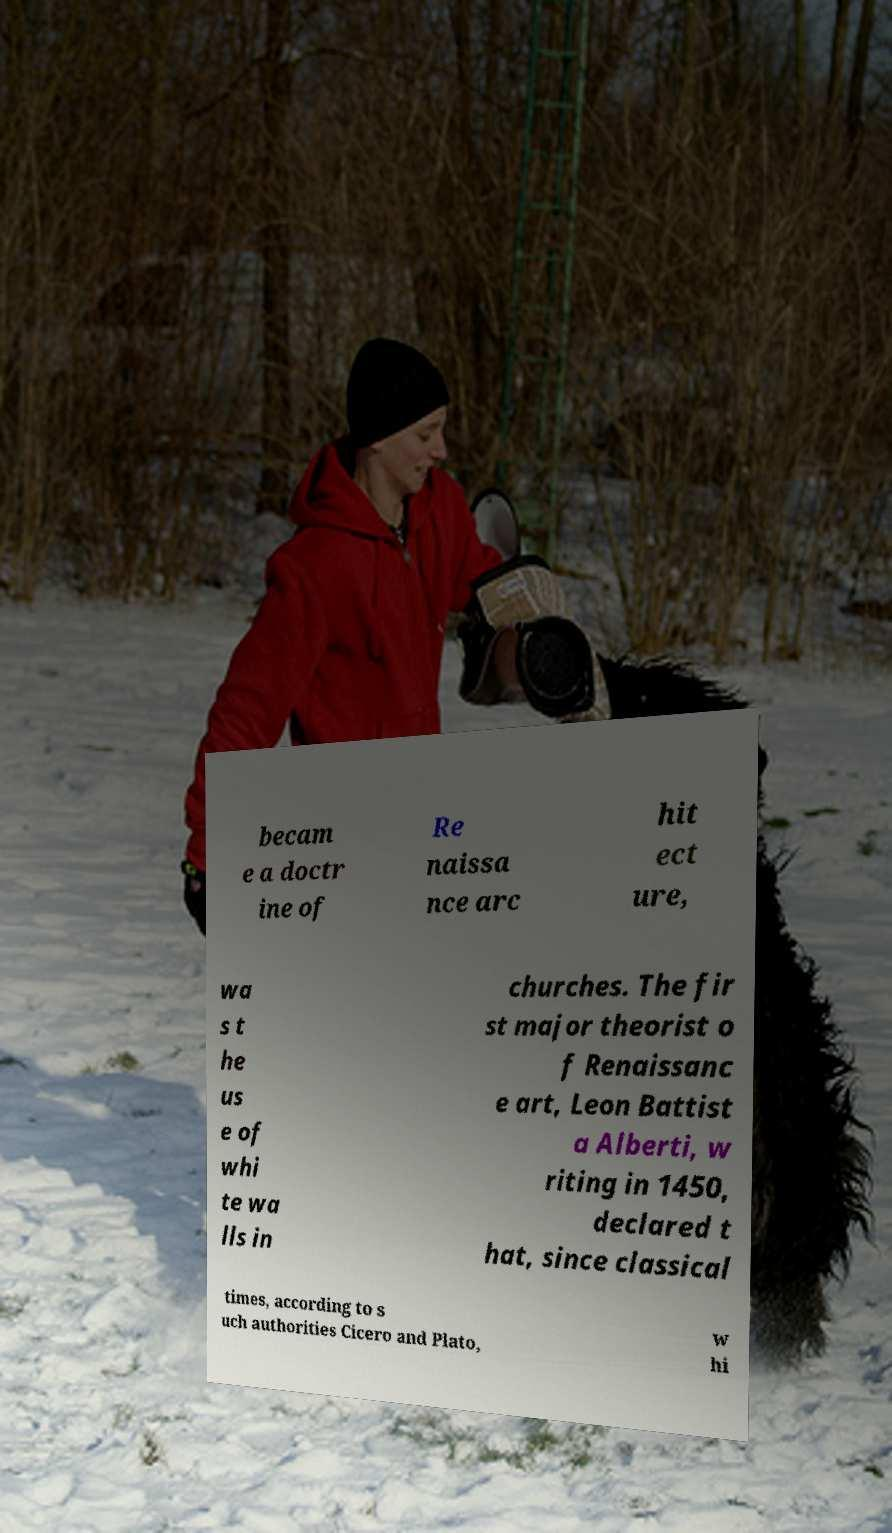There's text embedded in this image that I need extracted. Can you transcribe it verbatim? becam e a doctr ine of Re naissa nce arc hit ect ure, wa s t he us e of whi te wa lls in churches. The fir st major theorist o f Renaissanc e art, Leon Battist a Alberti, w riting in 1450, declared t hat, since classical times, according to s uch authorities Cicero and Plato, w hi 